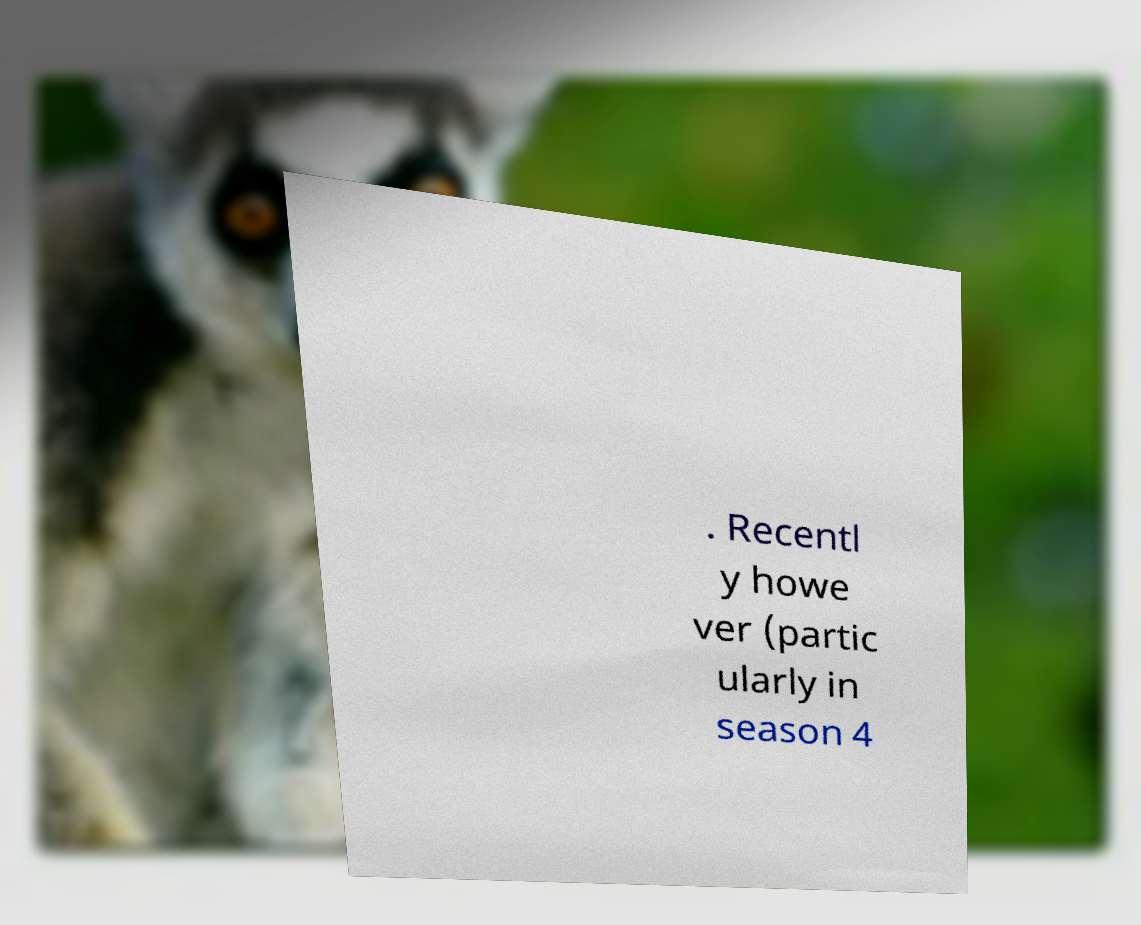Could you assist in decoding the text presented in this image and type it out clearly? . Recentl y howe ver (partic ularly in season 4 